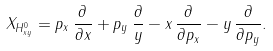Convert formula to latex. <formula><loc_0><loc_0><loc_500><loc_500>X _ { H ^ { 0 } _ { x y } } = p _ { x } \, \frac { \partial } { \partial x } + p _ { y } \, \frac { \partial } y - x \, \frac { \partial } { \partial p _ { x } } - y \, \frac { \partial } { \partial p _ { y } } .</formula> 